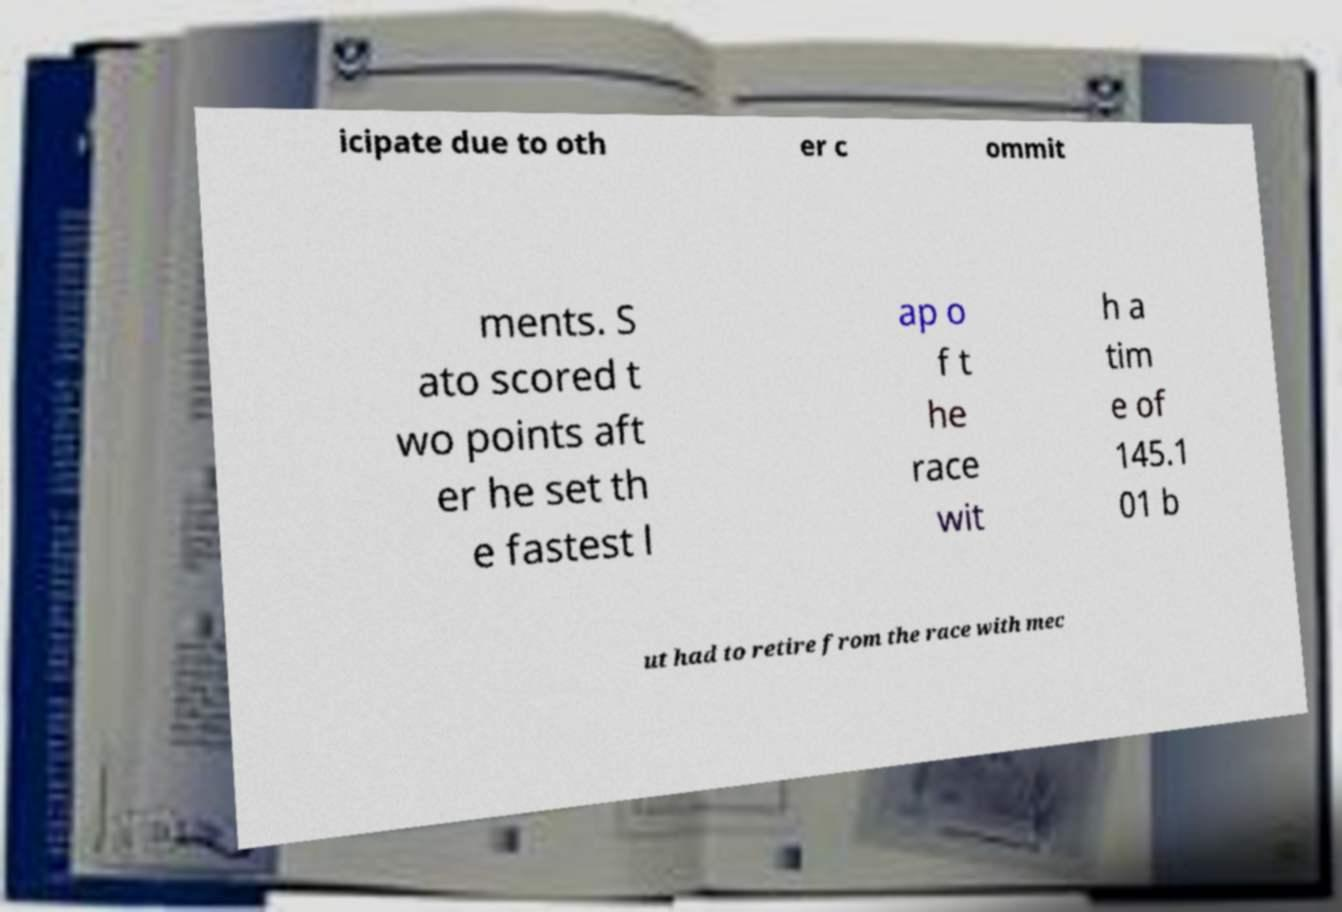Can you accurately transcribe the text from the provided image for me? icipate due to oth er c ommit ments. S ato scored t wo points aft er he set th e fastest l ap o f t he race wit h a tim e of 145.1 01 b ut had to retire from the race with mec 